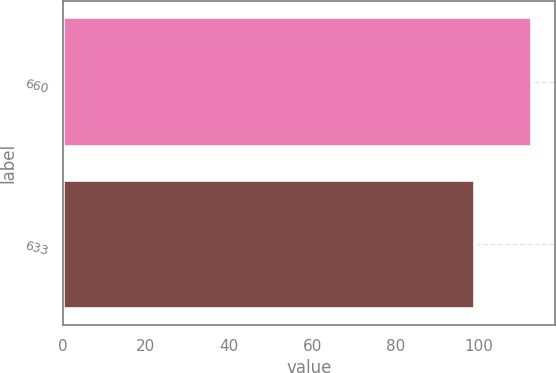Convert chart to OTSL. <chart><loc_0><loc_0><loc_500><loc_500><bar_chart><fcel>660<fcel>633<nl><fcel>112.7<fcel>99.1<nl></chart> 